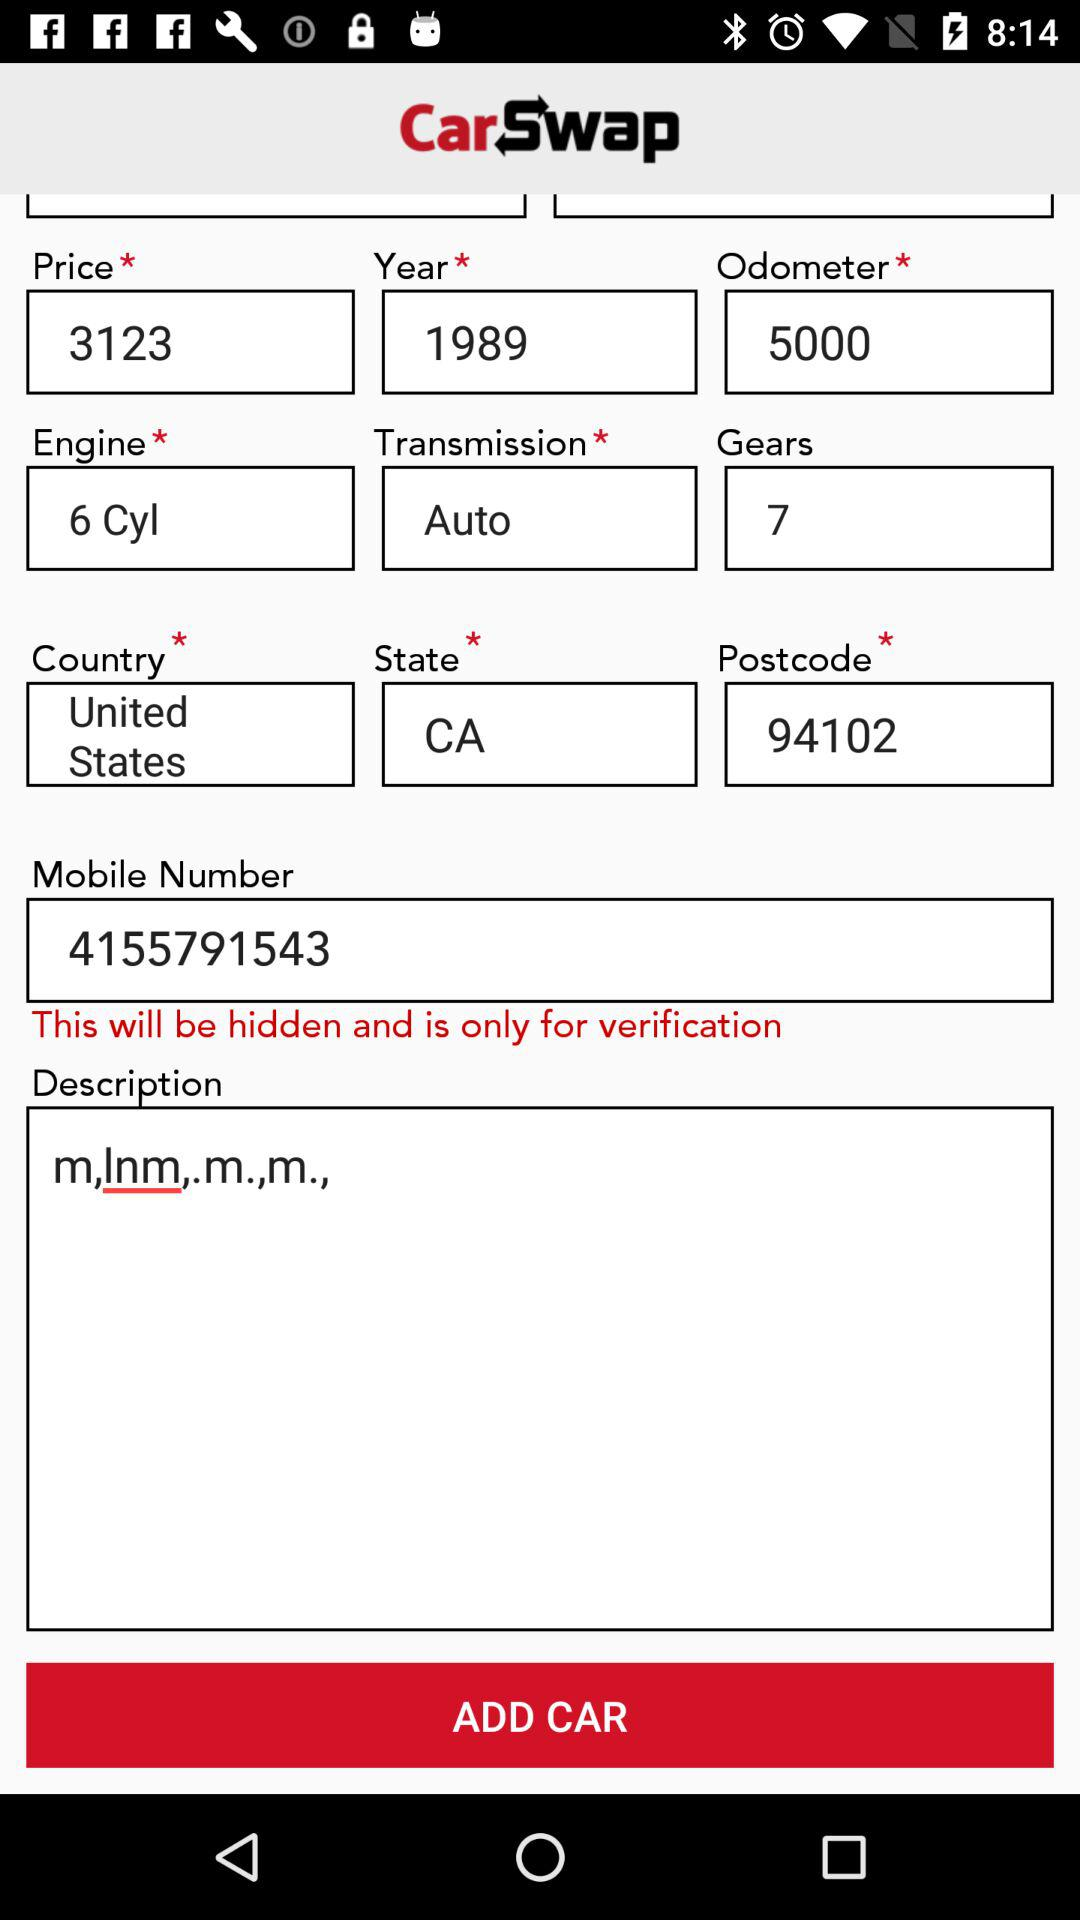What is the county name in the form? The county name is the United States. 